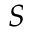<formula> <loc_0><loc_0><loc_500><loc_500>S</formula> 